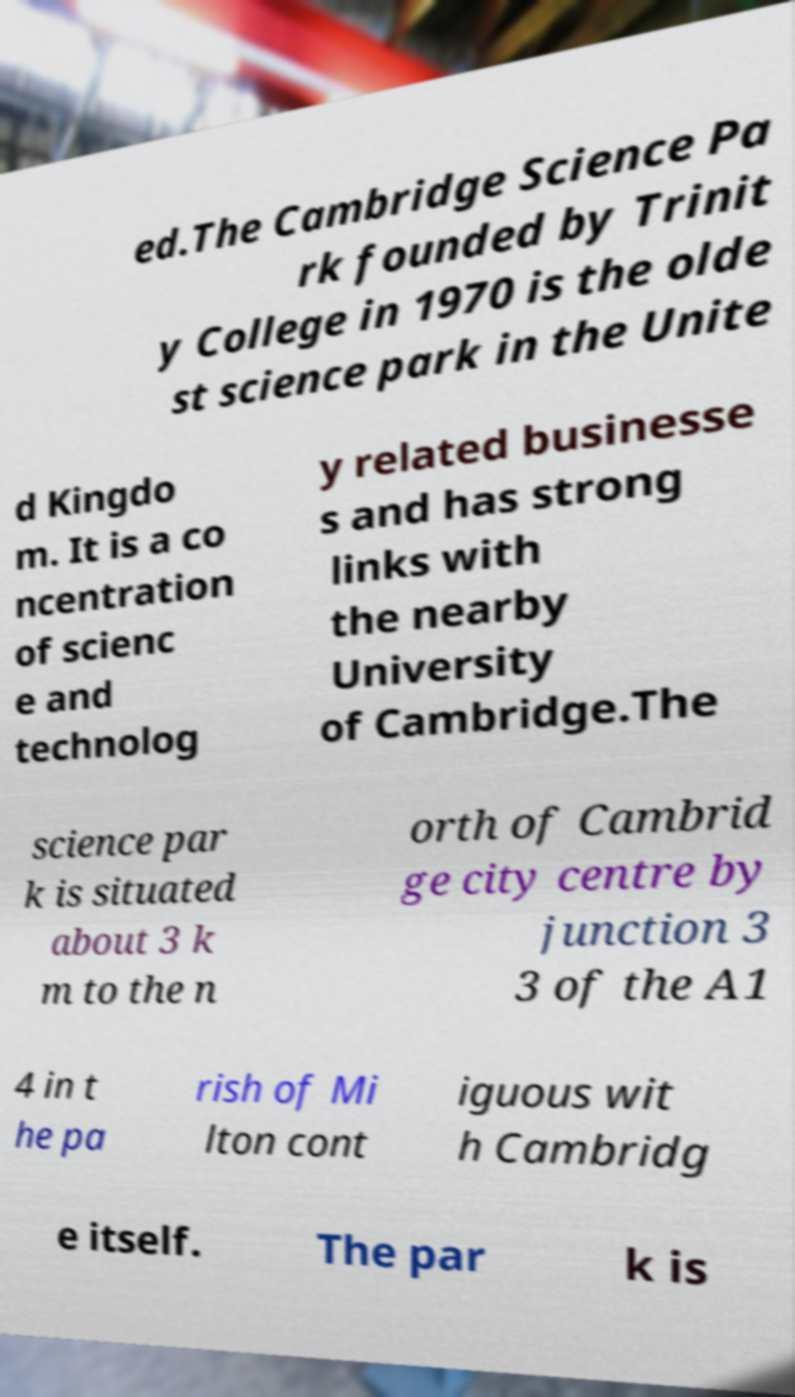I need the written content from this picture converted into text. Can you do that? ed.The Cambridge Science Pa rk founded by Trinit y College in 1970 is the olde st science park in the Unite d Kingdo m. It is a co ncentration of scienc e and technolog y related businesse s and has strong links with the nearby University of Cambridge.The science par k is situated about 3 k m to the n orth of Cambrid ge city centre by junction 3 3 of the A1 4 in t he pa rish of Mi lton cont iguous wit h Cambridg e itself. The par k is 